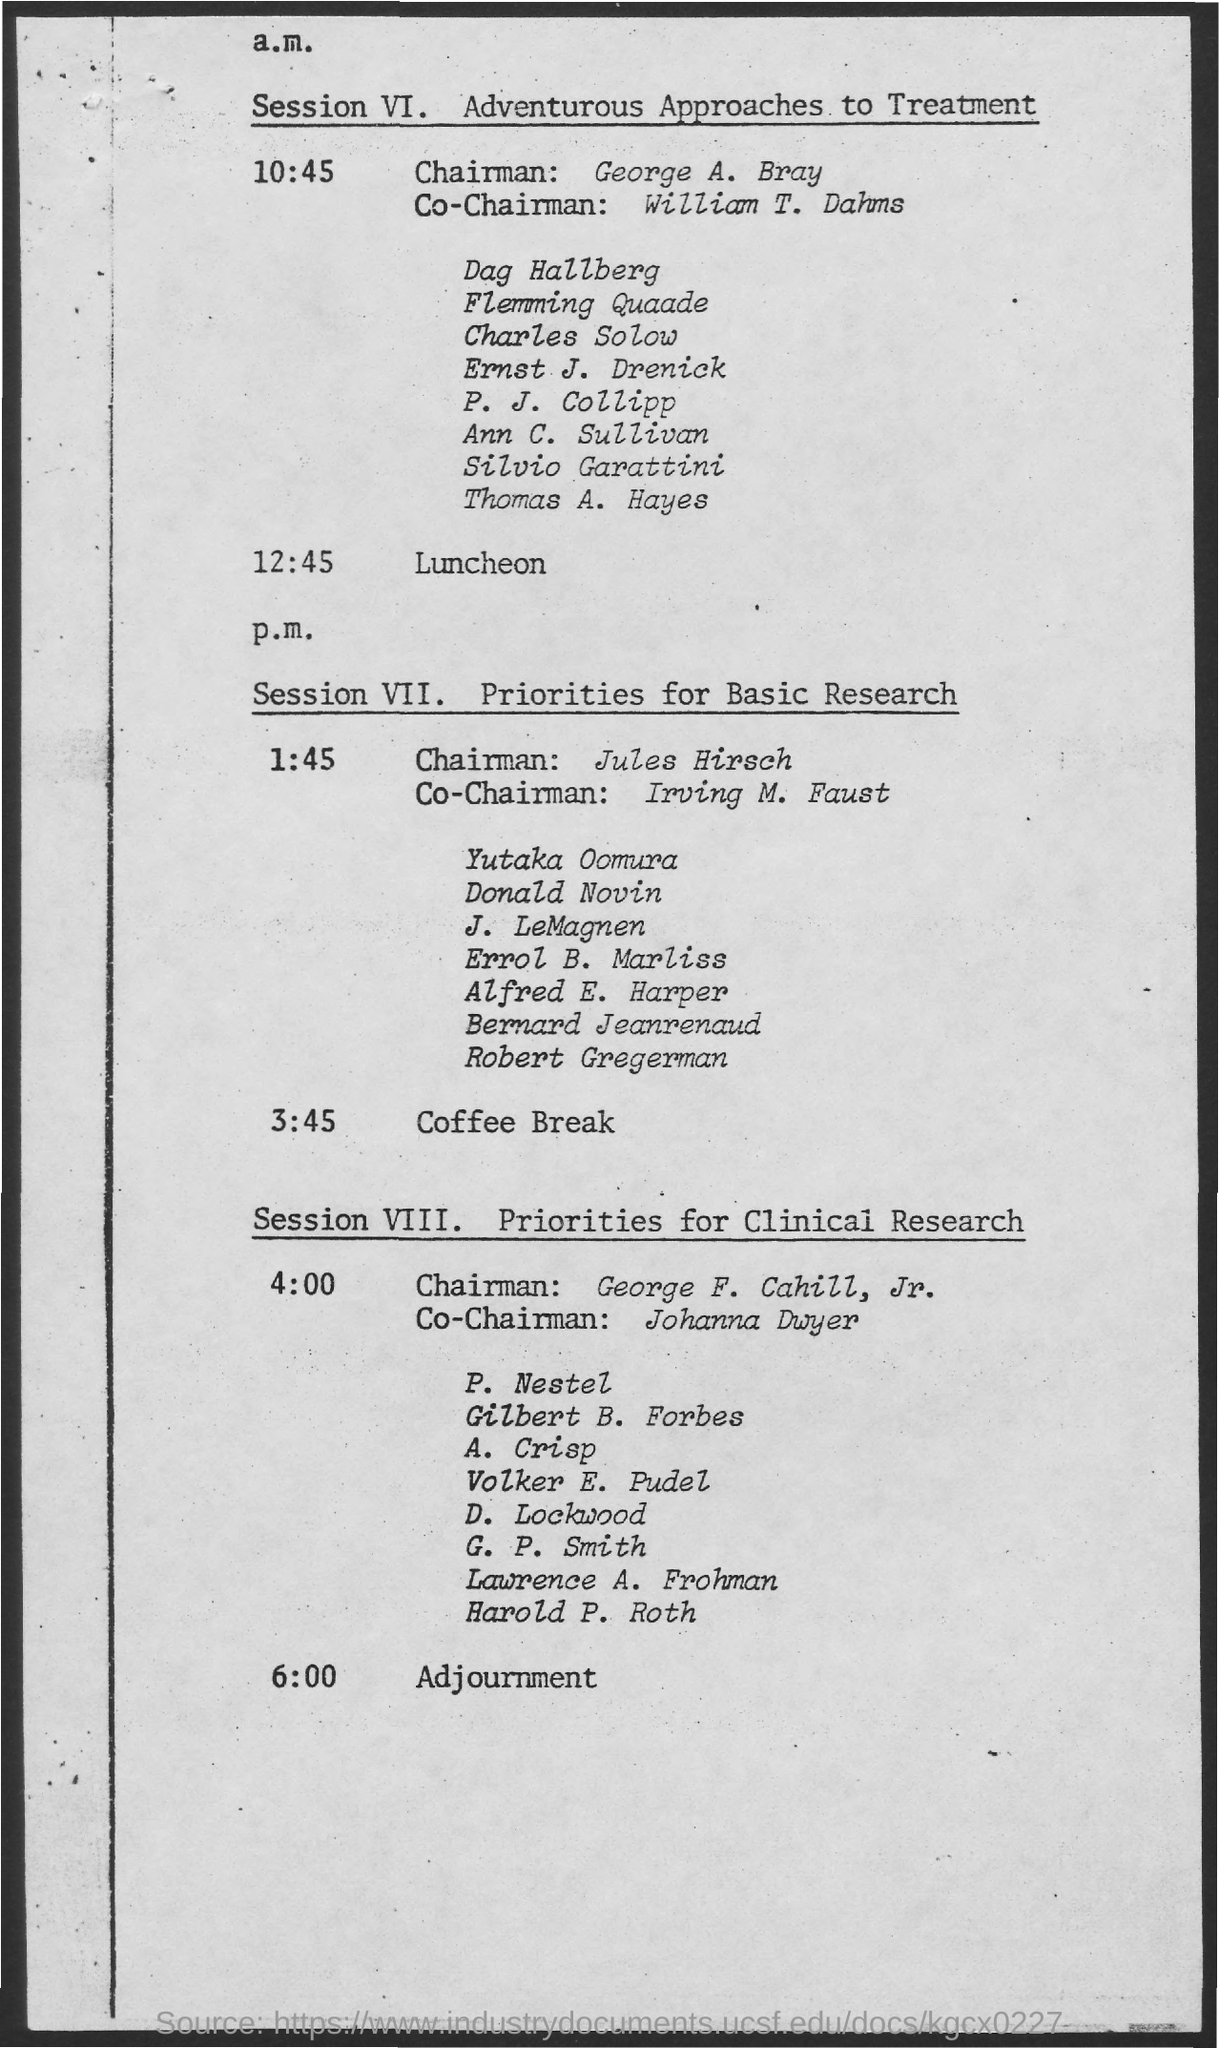Mention a couple of crucial points in this snapshot. The topic of Session VI is focused on adventurous approaches to treatment. The chairman for Session VIII is George F. Cahill, Jr. Jules Hirsch is the Chairman for Session VII. Session VIII is about discussing priorities for clinical research. William T. Dahms is the Co-Chairman for Session VI. 